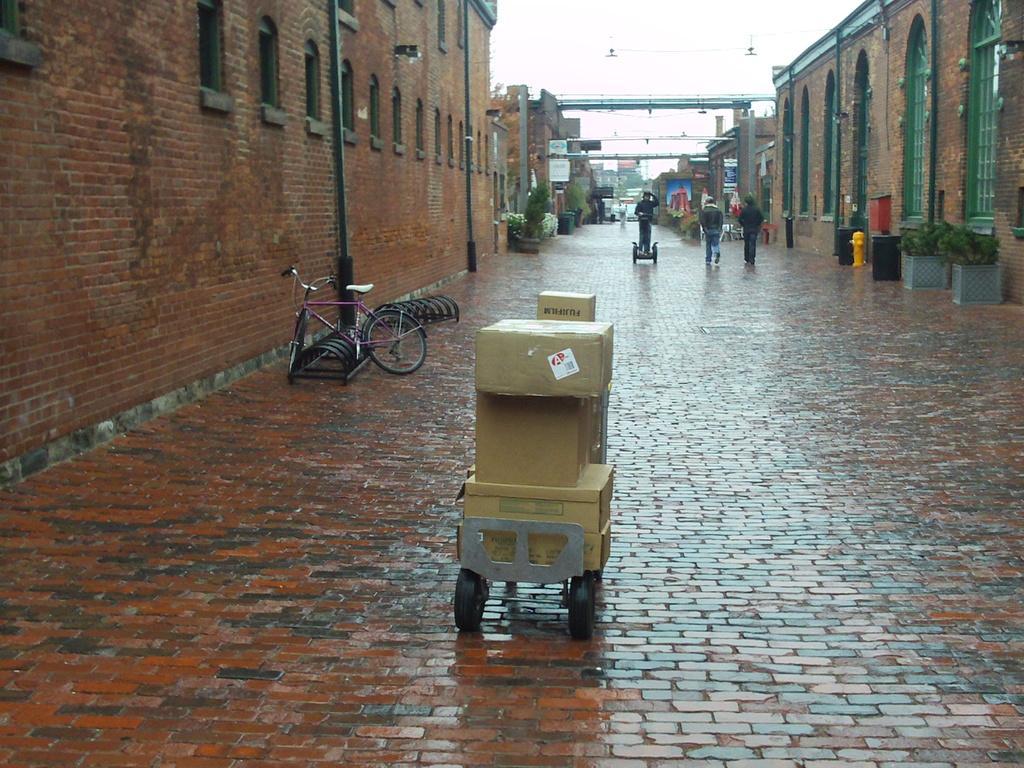In one or two sentences, can you explain what this image depicts? In this picture I can see two people were walking on the street. Beside them I can see many dustbins. At the bottom I can see the cotton boxes which are kept on this trolley. On the left there is a bicycle which is parked near to the brick wall. In the background I can see the plants, trees, banners, advertisement board, buildings and other objects. At the top there is a sky. 